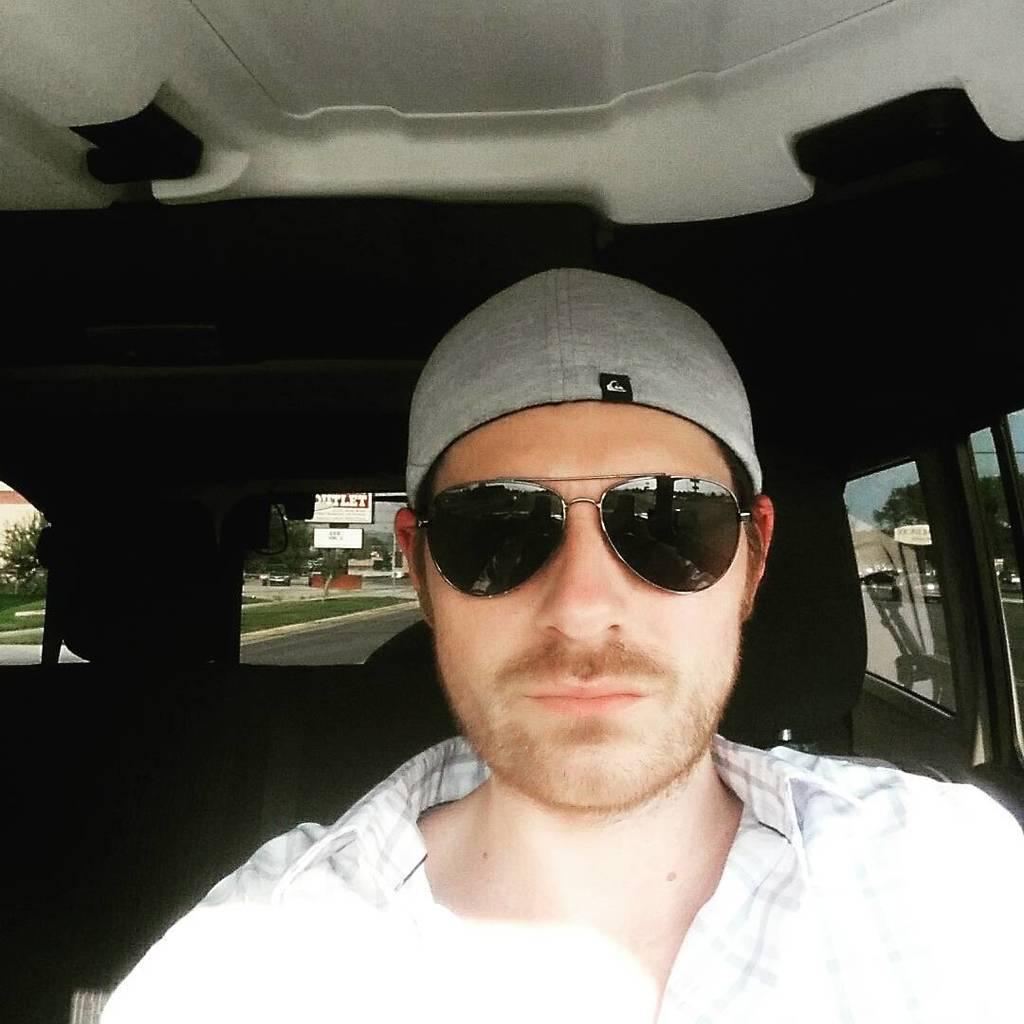What is the person in the image doing? The person is sitting in a car in the image. Can you describe the person's appearance? The person is wearing spectacles. What can be seen in the background of the image? There is a road, grass, trees, and houses visible in the background of the image. What type of cannon is present in the image? There is no cannon present in the image. How many brothers can be seen in the image? There is no mention of brothers in the image. 